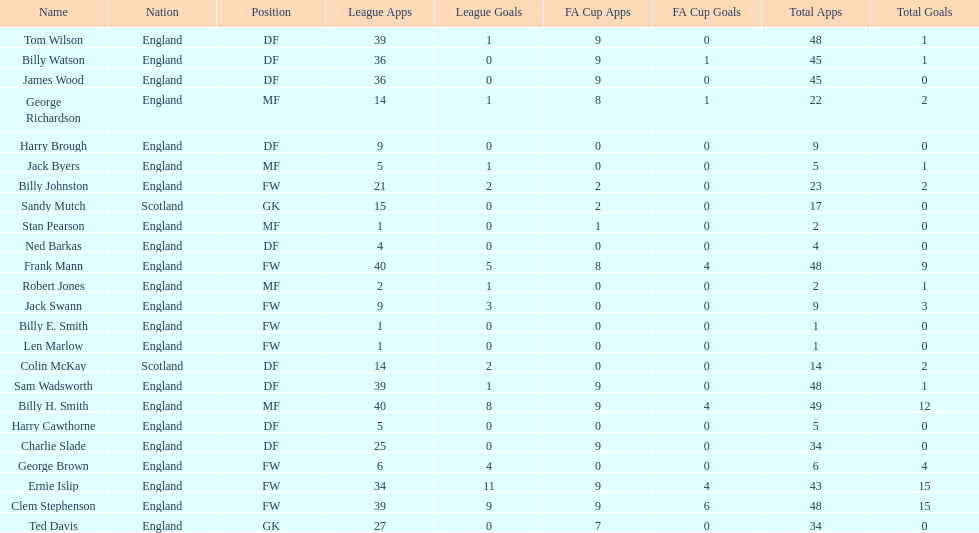What is the last name listed on this chart? James Wood. 